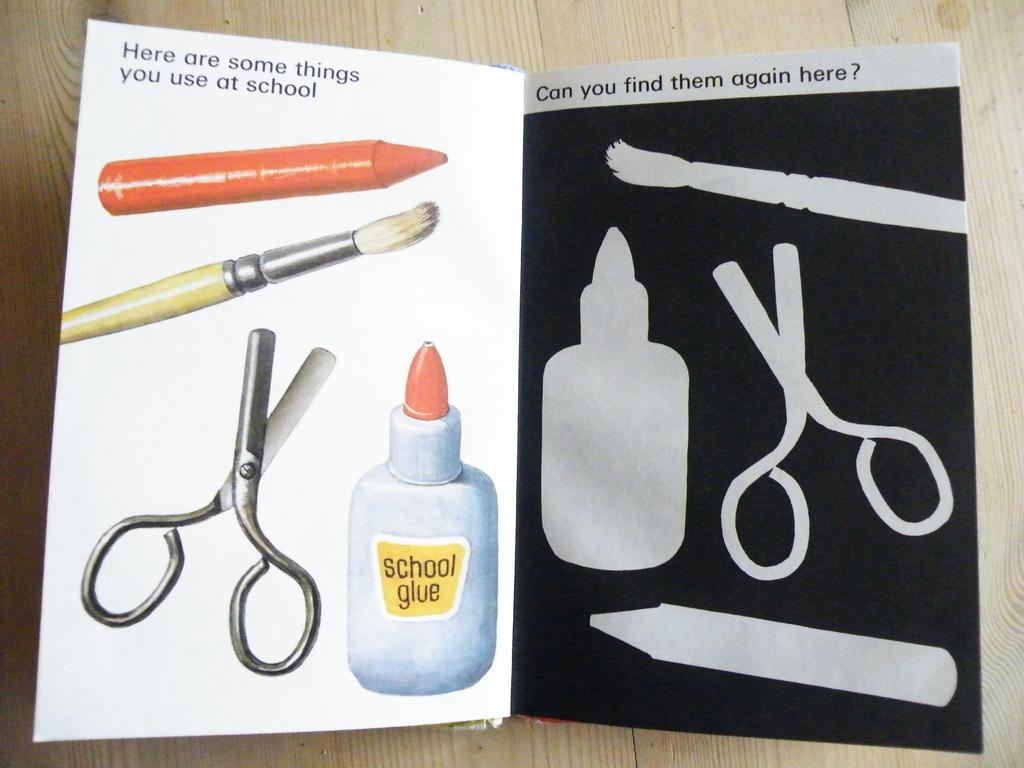What type of book is visible in the image? There is a craft book in the image. Where is the craft book located? The craft book is placed on a wooden table. What items can be found inside the craft book? There is a scissor, a bottle, a brush, and a crayon in the book. What type of doctor is attending to the carriage in the image? There is no doctor, carriage, or any related items present in the image. 